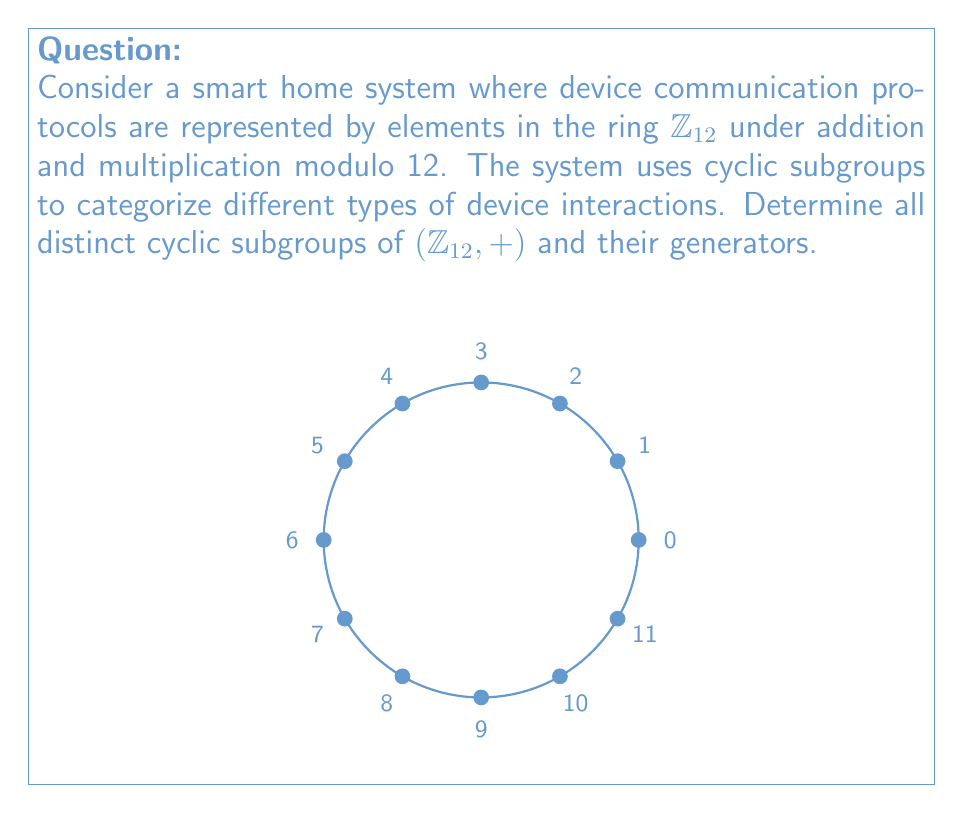Teach me how to tackle this problem. To find the cyclic subgroups of $(\mathbb{Z}_{12}, +)$, we need to determine the order of each element and identify the distinct subgroups generated. Let's follow these steps:

1) First, recall that in $\mathbb{Z}_{12}$, we have elements $\{0, 1, 2, ..., 11\}$.

2) For each element $a \in \mathbb{Z}_{12}$, we need to find the smallest positive integer $n$ such that $na \equiv 0 \pmod{12}$. This $n$ is the order of the element.

3) Let's calculate the order of each element:
   - $ord(0) = 1$
   - $ord(1) = 12$
   - $ord(2) = 6$
   - $ord(3) = 4$
   - $ord(4) = 3$
   - $ord(5) = 12$
   - $ord(6) = 2$
   - $ord(7) = 12$
   - $ord(8) = 3$
   - $ord(9) = 4$
   - $ord(10) = 6$
   - $ord(11) = 12$

4) Now, let's identify the distinct cyclic subgroups:
   - $\langle 0 \rangle = \{0\}$
   - $\langle 1 \rangle = \langle 5 \rangle = \langle 7 \rangle = \langle 11 \rangle = \{0, 1, 2, ..., 11\}$
   - $\langle 2 \rangle = \langle 10 \rangle = \{0, 2, 4, 6, 8, 10\}$
   - $\langle 3 \rangle = \langle 9 \rangle = \{0, 3, 6, 9\}$
   - $\langle 4 \rangle = \langle 8 \rangle = \{0, 4, 8\}$
   - $\langle 6 \rangle = \{0, 6\}$

5) Therefore, we have 6 distinct cyclic subgroups of $(\mathbb{Z}_{12}, +)$.

In the context of smart home device communication protocols, these subgroups could represent different categories of device interactions or communication cycles within the system.
Answer: The distinct cyclic subgroups of $(\mathbb{Z}_{12}, +)$ are:
$\{0\}$, $\{0,6\}$, $\{0,4,8\}$, $\{0,3,6,9\}$, $\{0,2,4,6,8,10\}$, and $\{0,1,2,3,4,5,6,7,8,9,10,11\}$. 